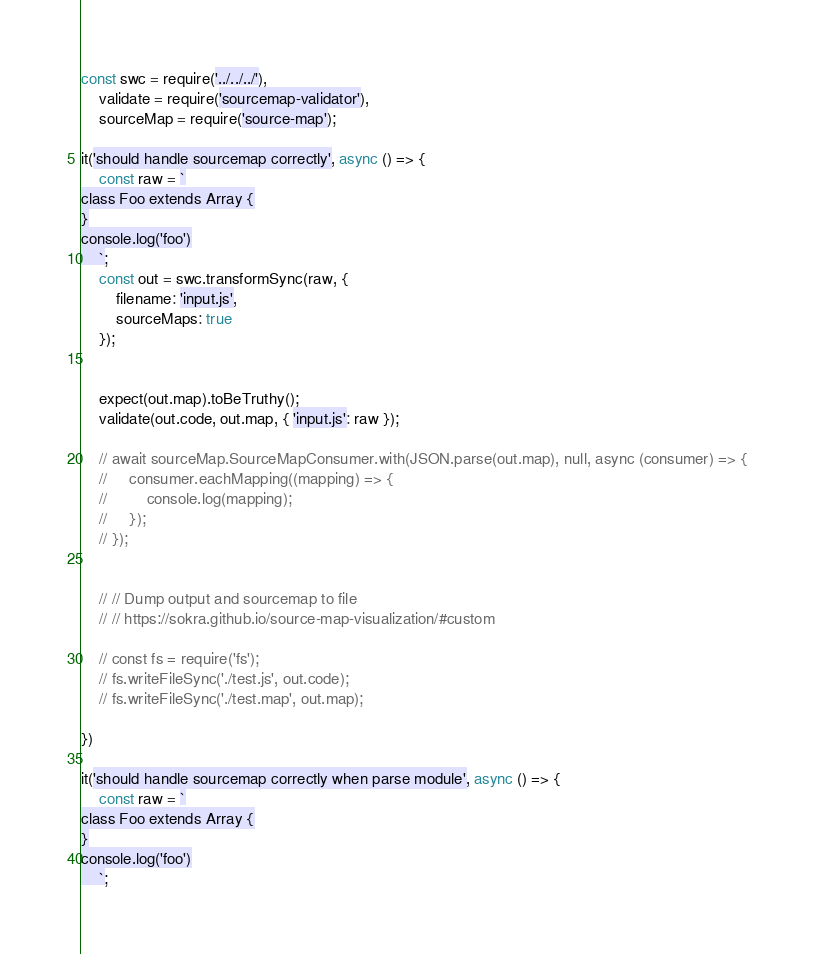Convert code to text. <code><loc_0><loc_0><loc_500><loc_500><_JavaScript_>const swc = require('../../../'),
    validate = require('sourcemap-validator'),
    sourceMap = require('source-map');

it('should handle sourcemap correctly', async () => {
    const raw = `
class Foo extends Array {
}
console.log('foo')
    `;
    const out = swc.transformSync(raw, {
        filename: 'input.js',
        sourceMaps: true
    });


    expect(out.map).toBeTruthy();
    validate(out.code, out.map, { 'input.js': raw });

    // await sourceMap.SourceMapConsumer.with(JSON.parse(out.map), null, async (consumer) => {
    //     consumer.eachMapping((mapping) => {
    //         console.log(mapping);
    //     });
    // });


    // // Dump output and sourcemap to file
    // // https://sokra.github.io/source-map-visualization/#custom

    // const fs = require('fs');
    // fs.writeFileSync('./test.js', out.code);
    // fs.writeFileSync('./test.map', out.map);

})

it('should handle sourcemap correctly when parse module', async () => {
    const raw = `
class Foo extends Array {
}
console.log('foo')
    `;</code> 